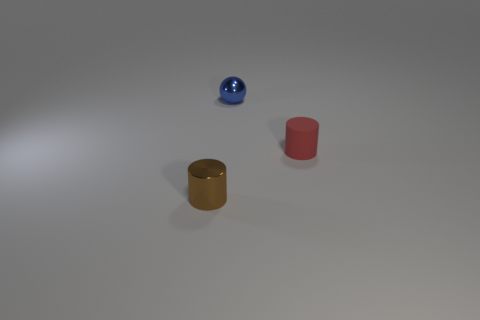Add 1 brown metallic cylinders. How many objects exist? 4 Subtract all brown cylinders. How many cylinders are left? 1 Add 3 big brown matte cubes. How many big brown matte cubes exist? 3 Subtract 1 brown cylinders. How many objects are left? 2 Subtract all cylinders. How many objects are left? 1 Subtract all gray cylinders. Subtract all red balls. How many cylinders are left? 2 Subtract all big blocks. Subtract all small matte things. How many objects are left? 2 Add 3 brown shiny things. How many brown shiny things are left? 4 